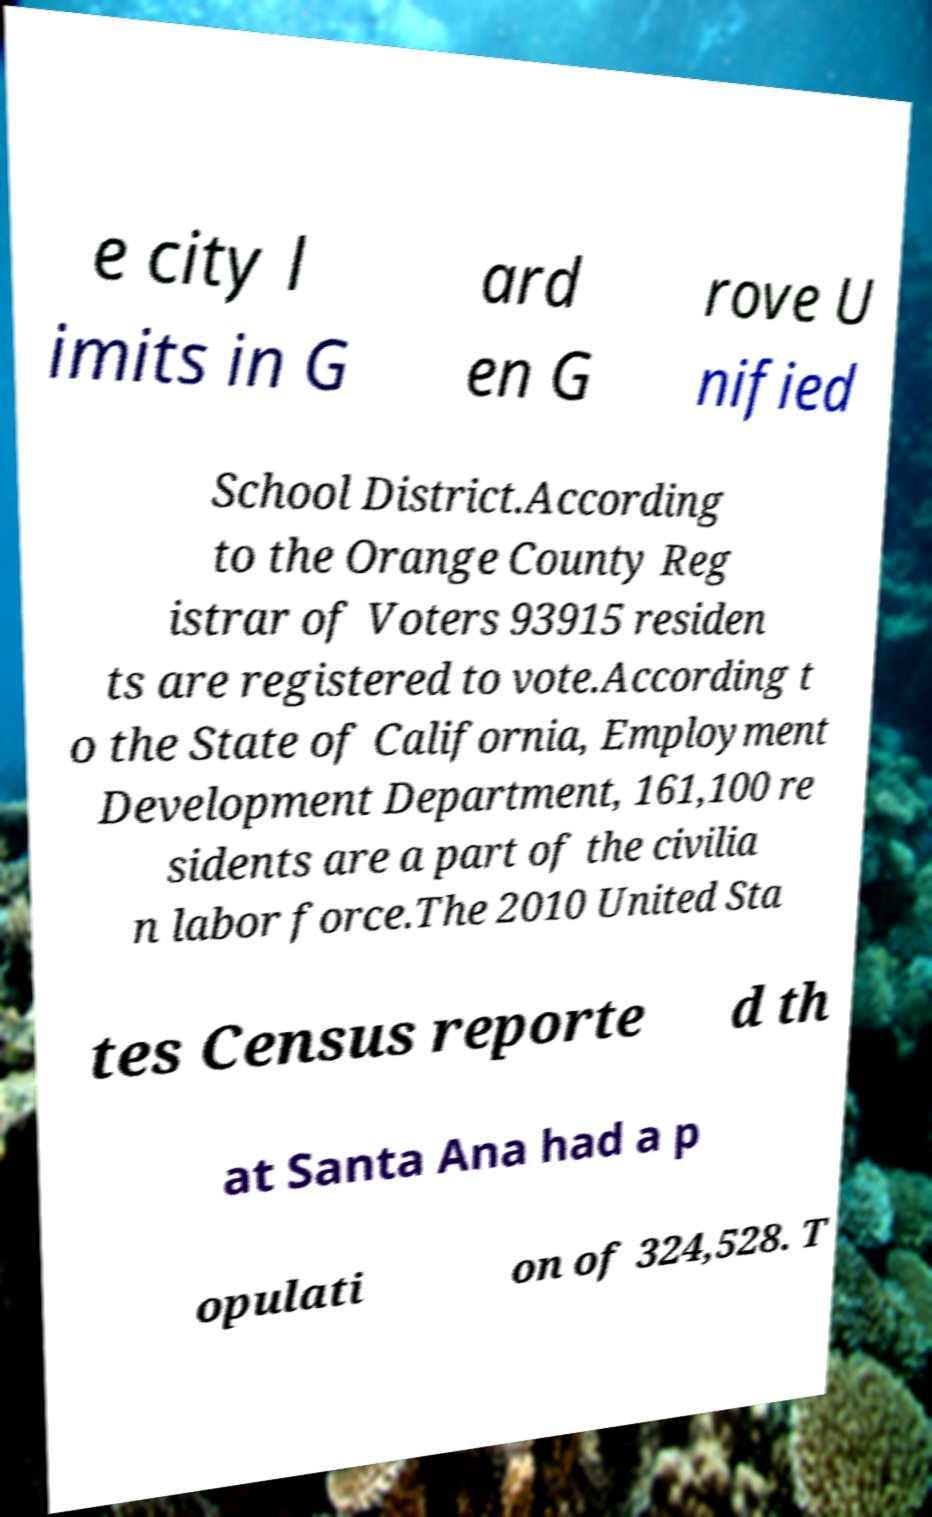Please read and relay the text visible in this image. What does it say? e city l imits in G ard en G rove U nified School District.According to the Orange County Reg istrar of Voters 93915 residen ts are registered to vote.According t o the State of California, Employment Development Department, 161,100 re sidents are a part of the civilia n labor force.The 2010 United Sta tes Census reporte d th at Santa Ana had a p opulati on of 324,528. T 